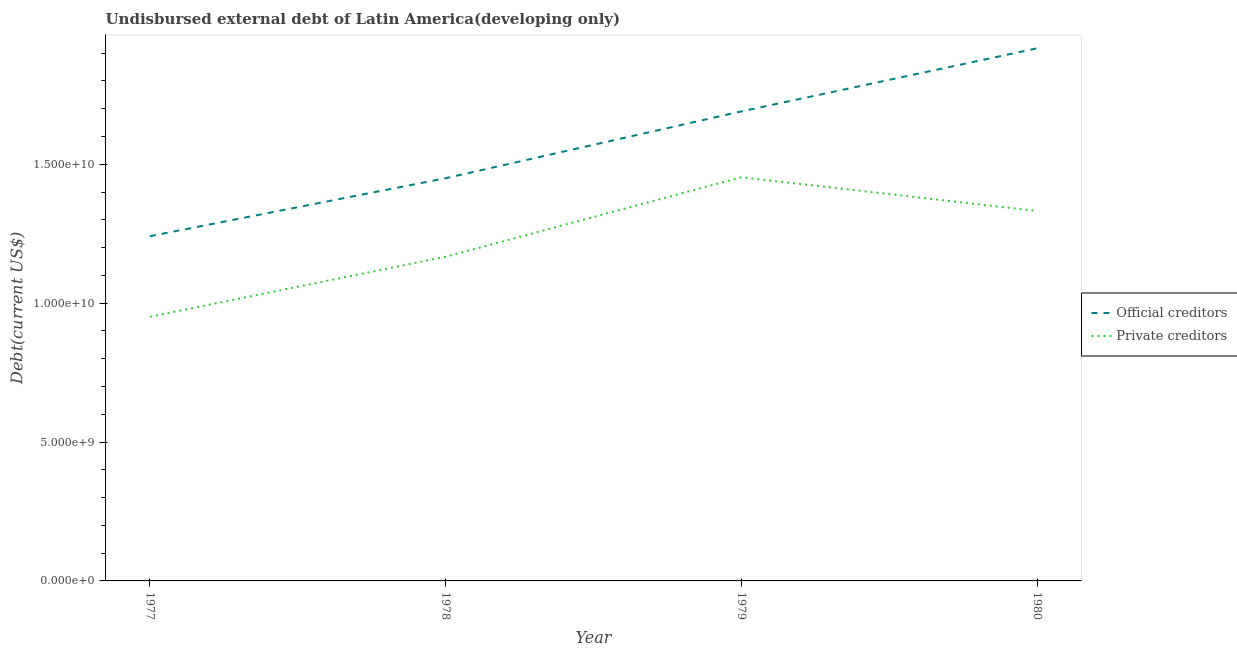How many different coloured lines are there?
Provide a succinct answer. 2. Is the number of lines equal to the number of legend labels?
Give a very brief answer. Yes. What is the undisbursed external debt of private creditors in 1977?
Provide a succinct answer. 9.51e+09. Across all years, what is the maximum undisbursed external debt of official creditors?
Offer a very short reply. 1.92e+1. Across all years, what is the minimum undisbursed external debt of official creditors?
Offer a very short reply. 1.24e+1. In which year was the undisbursed external debt of private creditors maximum?
Ensure brevity in your answer.  1979. In which year was the undisbursed external debt of official creditors minimum?
Your response must be concise. 1977. What is the total undisbursed external debt of official creditors in the graph?
Give a very brief answer. 6.30e+1. What is the difference between the undisbursed external debt of private creditors in 1979 and that in 1980?
Offer a very short reply. 1.22e+09. What is the difference between the undisbursed external debt of private creditors in 1980 and the undisbursed external debt of official creditors in 1977?
Ensure brevity in your answer.  9.06e+08. What is the average undisbursed external debt of private creditors per year?
Keep it short and to the point. 1.23e+1. In the year 1977, what is the difference between the undisbursed external debt of official creditors and undisbursed external debt of private creditors?
Your answer should be very brief. 2.90e+09. What is the ratio of the undisbursed external debt of private creditors in 1977 to that in 1980?
Give a very brief answer. 0.71. Is the undisbursed external debt of official creditors in 1978 less than that in 1980?
Offer a very short reply. Yes. Is the difference between the undisbursed external debt of private creditors in 1977 and 1980 greater than the difference between the undisbursed external debt of official creditors in 1977 and 1980?
Offer a terse response. Yes. What is the difference between the highest and the second highest undisbursed external debt of official creditors?
Ensure brevity in your answer.  2.27e+09. What is the difference between the highest and the lowest undisbursed external debt of private creditors?
Offer a very short reply. 5.02e+09. In how many years, is the undisbursed external debt of private creditors greater than the average undisbursed external debt of private creditors taken over all years?
Keep it short and to the point. 2. Is the undisbursed external debt of official creditors strictly greater than the undisbursed external debt of private creditors over the years?
Your response must be concise. Yes. Is the undisbursed external debt of private creditors strictly less than the undisbursed external debt of official creditors over the years?
Your answer should be very brief. Yes. How many years are there in the graph?
Your answer should be very brief. 4. What is the difference between two consecutive major ticks on the Y-axis?
Ensure brevity in your answer.  5.00e+09. Are the values on the major ticks of Y-axis written in scientific E-notation?
Your response must be concise. Yes. Does the graph contain any zero values?
Your response must be concise. No. Where does the legend appear in the graph?
Offer a terse response. Center right. How many legend labels are there?
Your answer should be very brief. 2. How are the legend labels stacked?
Offer a very short reply. Vertical. What is the title of the graph?
Ensure brevity in your answer.  Undisbursed external debt of Latin America(developing only). Does "Fertility rate" appear as one of the legend labels in the graph?
Provide a succinct answer. No. What is the label or title of the X-axis?
Your response must be concise. Year. What is the label or title of the Y-axis?
Make the answer very short. Debt(current US$). What is the Debt(current US$) of Official creditors in 1977?
Your answer should be very brief. 1.24e+1. What is the Debt(current US$) in Private creditors in 1977?
Offer a very short reply. 9.51e+09. What is the Debt(current US$) of Official creditors in 1978?
Your answer should be very brief. 1.45e+1. What is the Debt(current US$) of Private creditors in 1978?
Offer a very short reply. 1.17e+1. What is the Debt(current US$) of Official creditors in 1979?
Provide a succinct answer. 1.69e+1. What is the Debt(current US$) in Private creditors in 1979?
Your response must be concise. 1.45e+1. What is the Debt(current US$) in Official creditors in 1980?
Give a very brief answer. 1.92e+1. What is the Debt(current US$) of Private creditors in 1980?
Give a very brief answer. 1.33e+1. Across all years, what is the maximum Debt(current US$) of Official creditors?
Ensure brevity in your answer.  1.92e+1. Across all years, what is the maximum Debt(current US$) of Private creditors?
Make the answer very short. 1.45e+1. Across all years, what is the minimum Debt(current US$) of Official creditors?
Your response must be concise. 1.24e+1. Across all years, what is the minimum Debt(current US$) of Private creditors?
Ensure brevity in your answer.  9.51e+09. What is the total Debt(current US$) of Official creditors in the graph?
Provide a short and direct response. 6.30e+1. What is the total Debt(current US$) in Private creditors in the graph?
Offer a terse response. 4.90e+1. What is the difference between the Debt(current US$) of Official creditors in 1977 and that in 1978?
Keep it short and to the point. -2.09e+09. What is the difference between the Debt(current US$) of Private creditors in 1977 and that in 1978?
Offer a terse response. -2.16e+09. What is the difference between the Debt(current US$) of Official creditors in 1977 and that in 1979?
Ensure brevity in your answer.  -4.49e+09. What is the difference between the Debt(current US$) of Private creditors in 1977 and that in 1979?
Make the answer very short. -5.02e+09. What is the difference between the Debt(current US$) in Official creditors in 1977 and that in 1980?
Give a very brief answer. -6.76e+09. What is the difference between the Debt(current US$) of Private creditors in 1977 and that in 1980?
Give a very brief answer. -3.81e+09. What is the difference between the Debt(current US$) in Official creditors in 1978 and that in 1979?
Ensure brevity in your answer.  -2.41e+09. What is the difference between the Debt(current US$) of Private creditors in 1978 and that in 1979?
Your answer should be very brief. -2.86e+09. What is the difference between the Debt(current US$) of Official creditors in 1978 and that in 1980?
Make the answer very short. -4.68e+09. What is the difference between the Debt(current US$) of Private creditors in 1978 and that in 1980?
Give a very brief answer. -1.65e+09. What is the difference between the Debt(current US$) in Official creditors in 1979 and that in 1980?
Offer a very short reply. -2.27e+09. What is the difference between the Debt(current US$) in Private creditors in 1979 and that in 1980?
Ensure brevity in your answer.  1.22e+09. What is the difference between the Debt(current US$) in Official creditors in 1977 and the Debt(current US$) in Private creditors in 1978?
Offer a very short reply. 7.40e+08. What is the difference between the Debt(current US$) of Official creditors in 1977 and the Debt(current US$) of Private creditors in 1979?
Ensure brevity in your answer.  -2.12e+09. What is the difference between the Debt(current US$) in Official creditors in 1977 and the Debt(current US$) in Private creditors in 1980?
Your answer should be very brief. -9.06e+08. What is the difference between the Debt(current US$) in Official creditors in 1978 and the Debt(current US$) in Private creditors in 1979?
Your answer should be compact. -3.43e+07. What is the difference between the Debt(current US$) of Official creditors in 1978 and the Debt(current US$) of Private creditors in 1980?
Offer a very short reply. 1.18e+09. What is the difference between the Debt(current US$) of Official creditors in 1979 and the Debt(current US$) of Private creditors in 1980?
Provide a short and direct response. 3.59e+09. What is the average Debt(current US$) of Official creditors per year?
Provide a succinct answer. 1.57e+1. What is the average Debt(current US$) of Private creditors per year?
Your answer should be compact. 1.23e+1. In the year 1977, what is the difference between the Debt(current US$) in Official creditors and Debt(current US$) in Private creditors?
Ensure brevity in your answer.  2.90e+09. In the year 1978, what is the difference between the Debt(current US$) of Official creditors and Debt(current US$) of Private creditors?
Give a very brief answer. 2.83e+09. In the year 1979, what is the difference between the Debt(current US$) of Official creditors and Debt(current US$) of Private creditors?
Your answer should be compact. 2.37e+09. In the year 1980, what is the difference between the Debt(current US$) of Official creditors and Debt(current US$) of Private creditors?
Keep it short and to the point. 5.86e+09. What is the ratio of the Debt(current US$) of Official creditors in 1977 to that in 1978?
Your answer should be very brief. 0.86. What is the ratio of the Debt(current US$) in Private creditors in 1977 to that in 1978?
Offer a terse response. 0.81. What is the ratio of the Debt(current US$) of Official creditors in 1977 to that in 1979?
Give a very brief answer. 0.73. What is the ratio of the Debt(current US$) of Private creditors in 1977 to that in 1979?
Your response must be concise. 0.65. What is the ratio of the Debt(current US$) of Official creditors in 1977 to that in 1980?
Provide a short and direct response. 0.65. What is the ratio of the Debt(current US$) of Private creditors in 1977 to that in 1980?
Your response must be concise. 0.71. What is the ratio of the Debt(current US$) of Official creditors in 1978 to that in 1979?
Your response must be concise. 0.86. What is the ratio of the Debt(current US$) of Private creditors in 1978 to that in 1979?
Provide a short and direct response. 0.8. What is the ratio of the Debt(current US$) of Official creditors in 1978 to that in 1980?
Your answer should be compact. 0.76. What is the ratio of the Debt(current US$) in Private creditors in 1978 to that in 1980?
Keep it short and to the point. 0.88. What is the ratio of the Debt(current US$) of Official creditors in 1979 to that in 1980?
Your answer should be compact. 0.88. What is the ratio of the Debt(current US$) in Private creditors in 1979 to that in 1980?
Provide a succinct answer. 1.09. What is the difference between the highest and the second highest Debt(current US$) in Official creditors?
Give a very brief answer. 2.27e+09. What is the difference between the highest and the second highest Debt(current US$) of Private creditors?
Your answer should be very brief. 1.22e+09. What is the difference between the highest and the lowest Debt(current US$) of Official creditors?
Keep it short and to the point. 6.76e+09. What is the difference between the highest and the lowest Debt(current US$) of Private creditors?
Ensure brevity in your answer.  5.02e+09. 